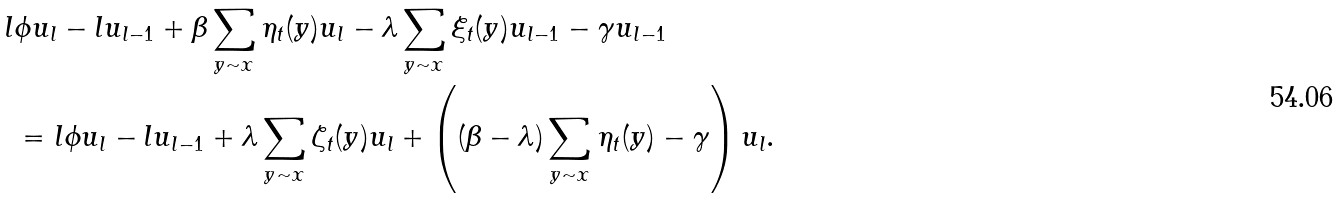<formula> <loc_0><loc_0><loc_500><loc_500>l & \phi u _ { l } - l u _ { l - 1 } + \beta \sum _ { y \sim x } \eta _ { t } ( y ) u _ { l } - \lambda \sum _ { y \sim x } \xi _ { t } ( y ) u _ { l - 1 } - \gamma u _ { l - 1 } \\ & = l \phi u _ { l } - l u _ { l - 1 } + \lambda \sum _ { y \sim x } \zeta _ { t } ( y ) u _ { l } + \left ( ( \beta - \lambda ) \sum _ { y \sim x } \eta _ { t } ( y ) - \gamma \right ) u _ { l } .</formula> 